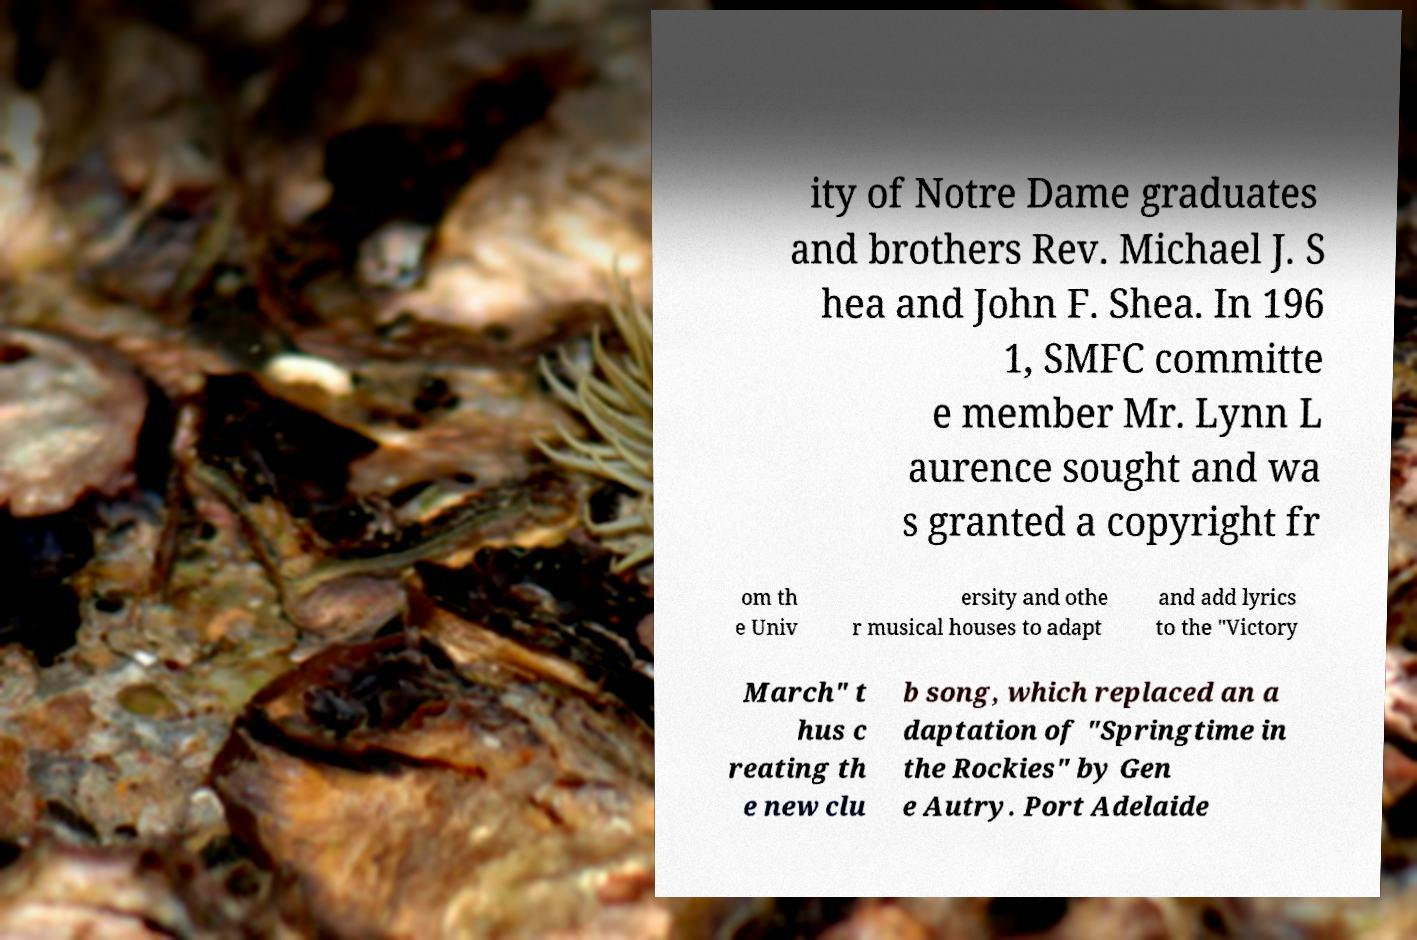For documentation purposes, I need the text within this image transcribed. Could you provide that? ity of Notre Dame graduates and brothers Rev. Michael J. S hea and John F. Shea. In 196 1, SMFC committe e member Mr. Lynn L aurence sought and wa s granted a copyright fr om th e Univ ersity and othe r musical houses to adapt and add lyrics to the "Victory March" t hus c reating th e new clu b song, which replaced an a daptation of "Springtime in the Rockies" by Gen e Autry. Port Adelaide 